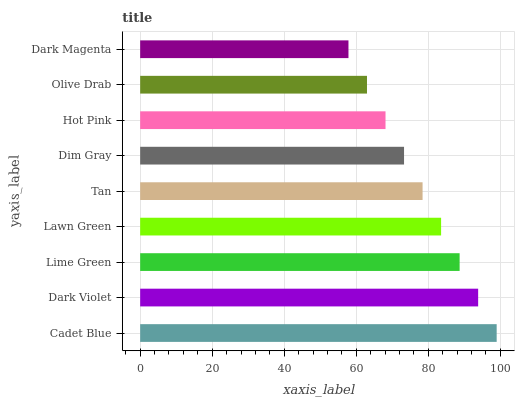Is Dark Magenta the minimum?
Answer yes or no. Yes. Is Cadet Blue the maximum?
Answer yes or no. Yes. Is Dark Violet the minimum?
Answer yes or no. No. Is Dark Violet the maximum?
Answer yes or no. No. Is Cadet Blue greater than Dark Violet?
Answer yes or no. Yes. Is Dark Violet less than Cadet Blue?
Answer yes or no. Yes. Is Dark Violet greater than Cadet Blue?
Answer yes or no. No. Is Cadet Blue less than Dark Violet?
Answer yes or no. No. Is Tan the high median?
Answer yes or no. Yes. Is Tan the low median?
Answer yes or no. Yes. Is Hot Pink the high median?
Answer yes or no. No. Is Hot Pink the low median?
Answer yes or no. No. 